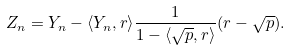Convert formula to latex. <formula><loc_0><loc_0><loc_500><loc_500>Z _ { n } = Y _ { n } - \langle Y _ { n } , r \rangle \frac { 1 } { 1 - \langle \sqrt { p } , r \rangle } ( r - \sqrt { p } ) .</formula> 